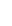<formula> <loc_0><loc_0><loc_500><loc_500>\begin{smallmatrix} \\ \\ \\ \\ \end{smallmatrix}</formula> 